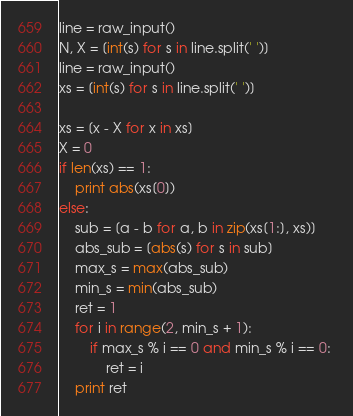<code> <loc_0><loc_0><loc_500><loc_500><_Python_>line = raw_input()
N, X = [int(s) for s in line.split(' ')]
line = raw_input()
xs = [int(s) for s in line.split(' ')]

xs = [x - X for x in xs]
X = 0
if len(xs) == 1:
    print abs(xs[0])
else:
    sub = [a - b for a, b in zip(xs[1:], xs)]
    abs_sub = [abs(s) for s in sub]
    max_s = max(abs_sub)
    min_s = min(abs_sub)
    ret = 1
    for i in range(2, min_s + 1):
        if max_s % i == 0 and min_s % i == 0: 
            ret = i
    print ret
</code> 